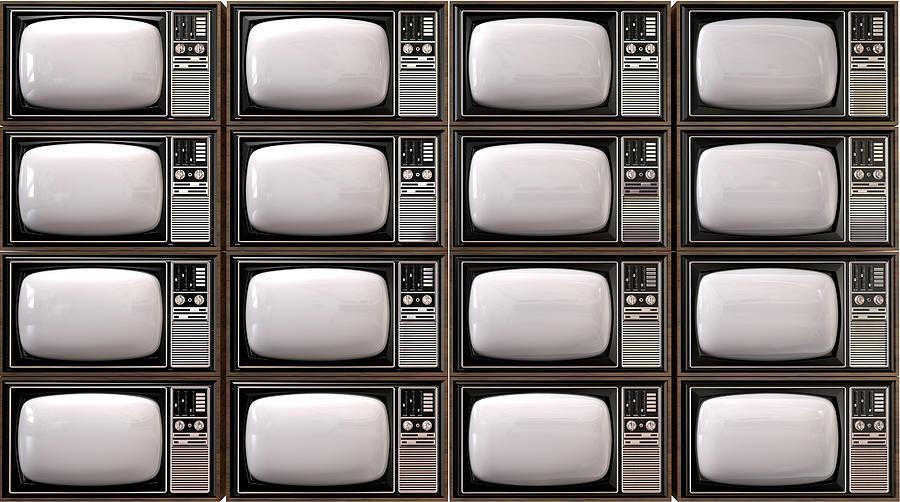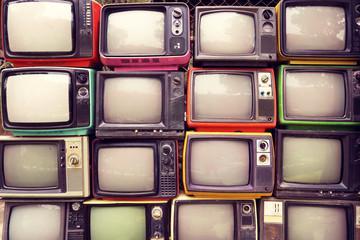The first image is the image on the left, the second image is the image on the right. Assess this claim about the two images: "The left image contains at least one old-fashioned TV with controls to the right of a slightly rounded square screen, which is glowing green.". Correct or not? Answer yes or no. No. The first image is the image on the left, the second image is the image on the right. Considering the images on both sides, is "At least one television's display is bright green." valid? Answer yes or no. No. 